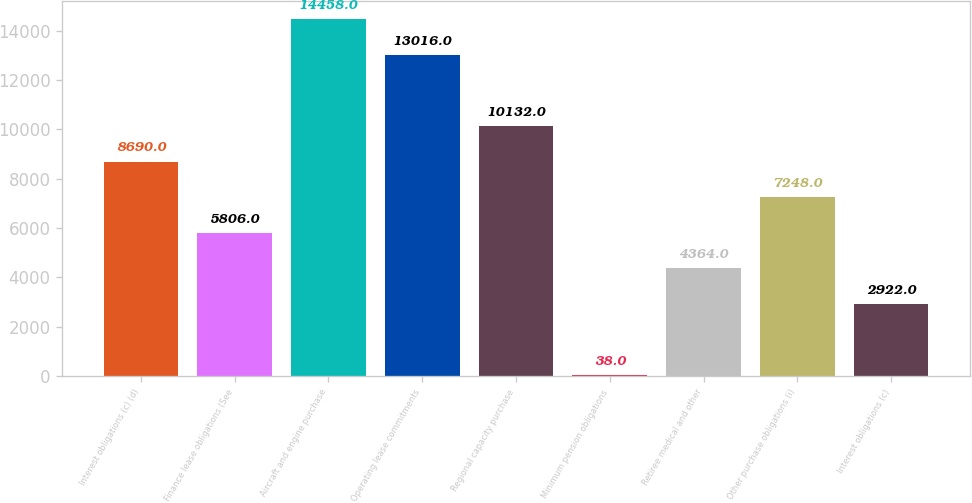Convert chart to OTSL. <chart><loc_0><loc_0><loc_500><loc_500><bar_chart><fcel>Interest obligations (c) (d)<fcel>Finance lease obligations (See<fcel>Aircraft and engine purchase<fcel>Operating lease commitments<fcel>Regional capacity purchase<fcel>Minimum pension obligations<fcel>Retiree medical and other<fcel>Other purchase obligations (i)<fcel>Interest obligations (c)<nl><fcel>8690<fcel>5806<fcel>14458<fcel>13016<fcel>10132<fcel>38<fcel>4364<fcel>7248<fcel>2922<nl></chart> 